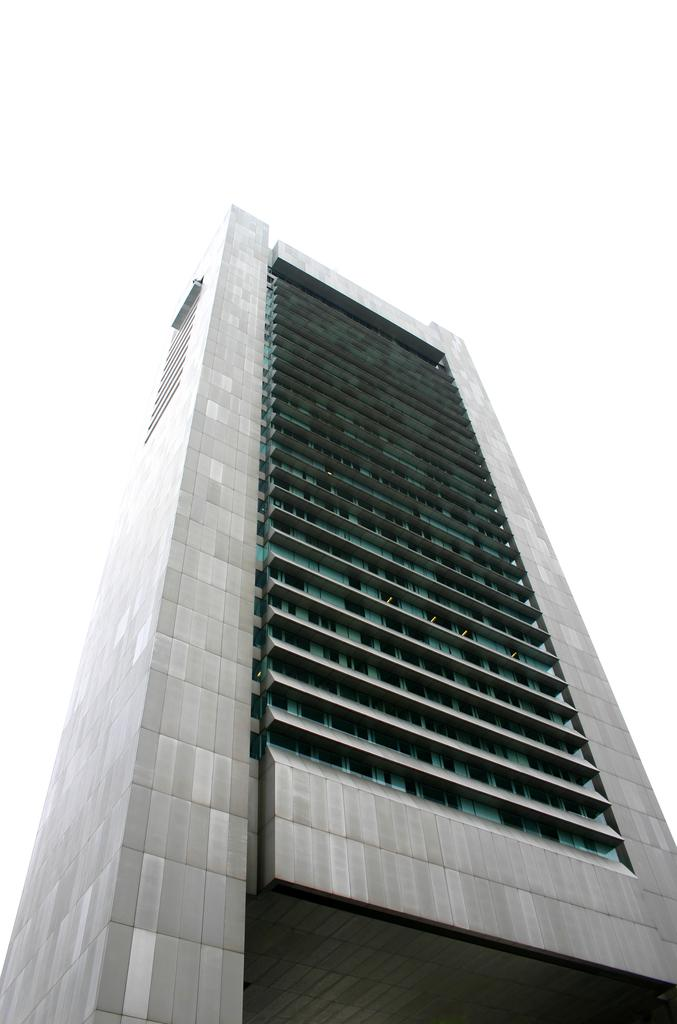What type of structure is present in the image? There is a building in the image. What part of the natural environment can be seen in the image? The sky is visible in the image. What type of fruit is hanging from the building in the image? There is no fruit hanging from the building in the image. How many screws can be seen on the building in the image? There is no information about screws on the building in the image. 